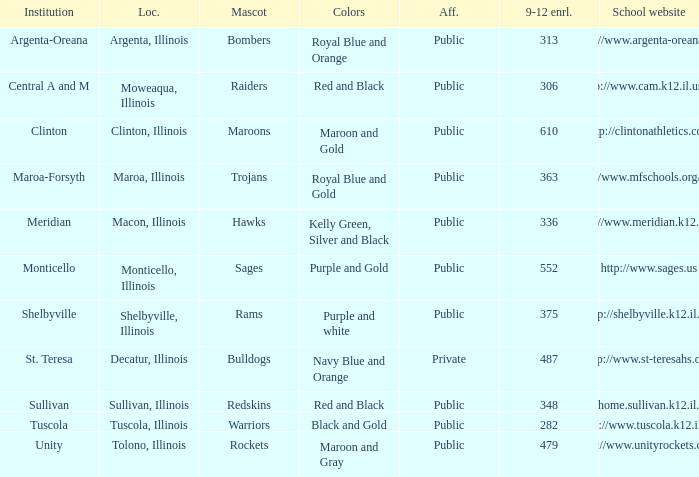What colors can you see players from Tolono, Illinois wearing? Maroon and Gray. 